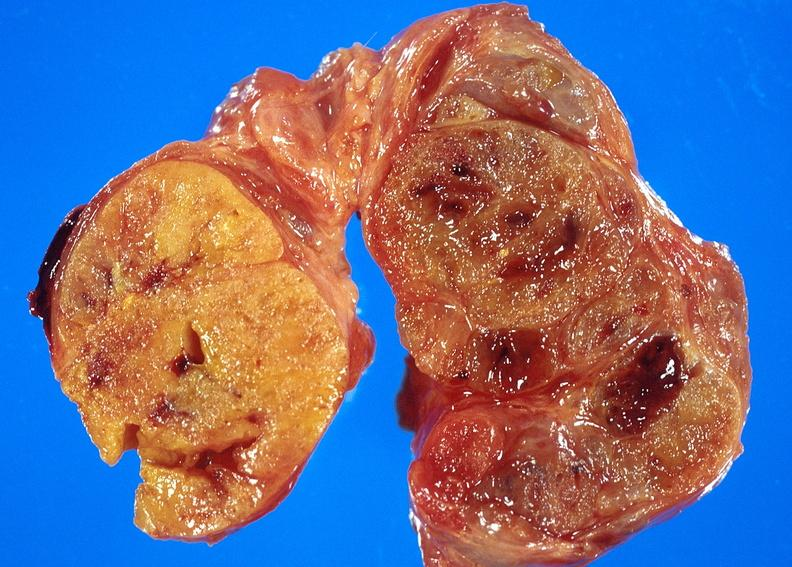what is present?
Answer the question using a single word or phrase. Endocrine 